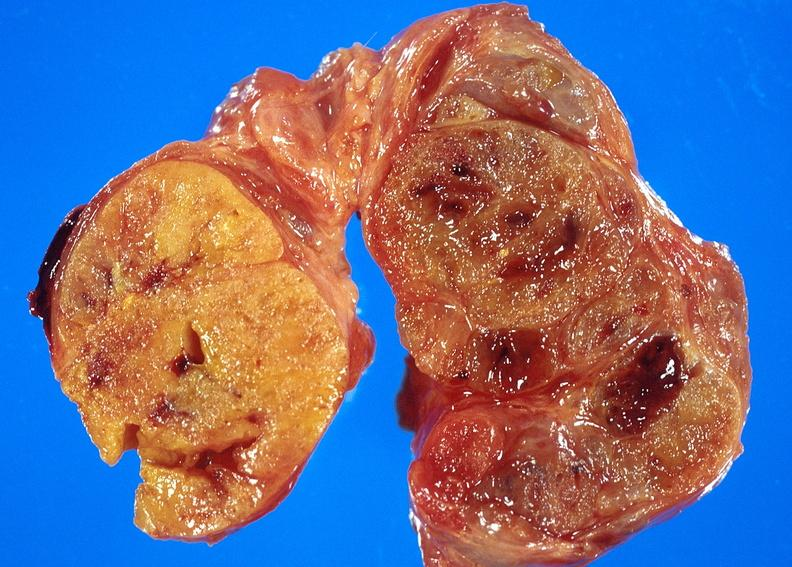what is present?
Answer the question using a single word or phrase. Endocrine 